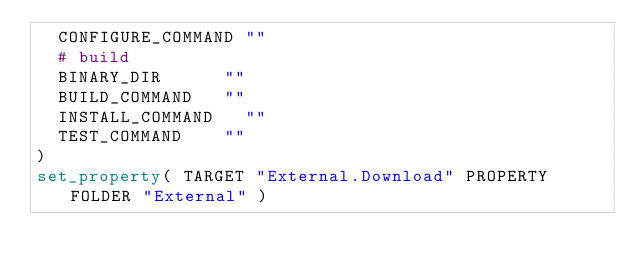<code> <loc_0><loc_0><loc_500><loc_500><_CMake_>	CONFIGURE_COMMAND	""
	# build
	BINARY_DIR			""
	BUILD_COMMAND		""
	INSTALL_COMMAND		""
	TEST_COMMAND		""
)
set_property( TARGET "External.Download" PROPERTY FOLDER "External" )
</code> 